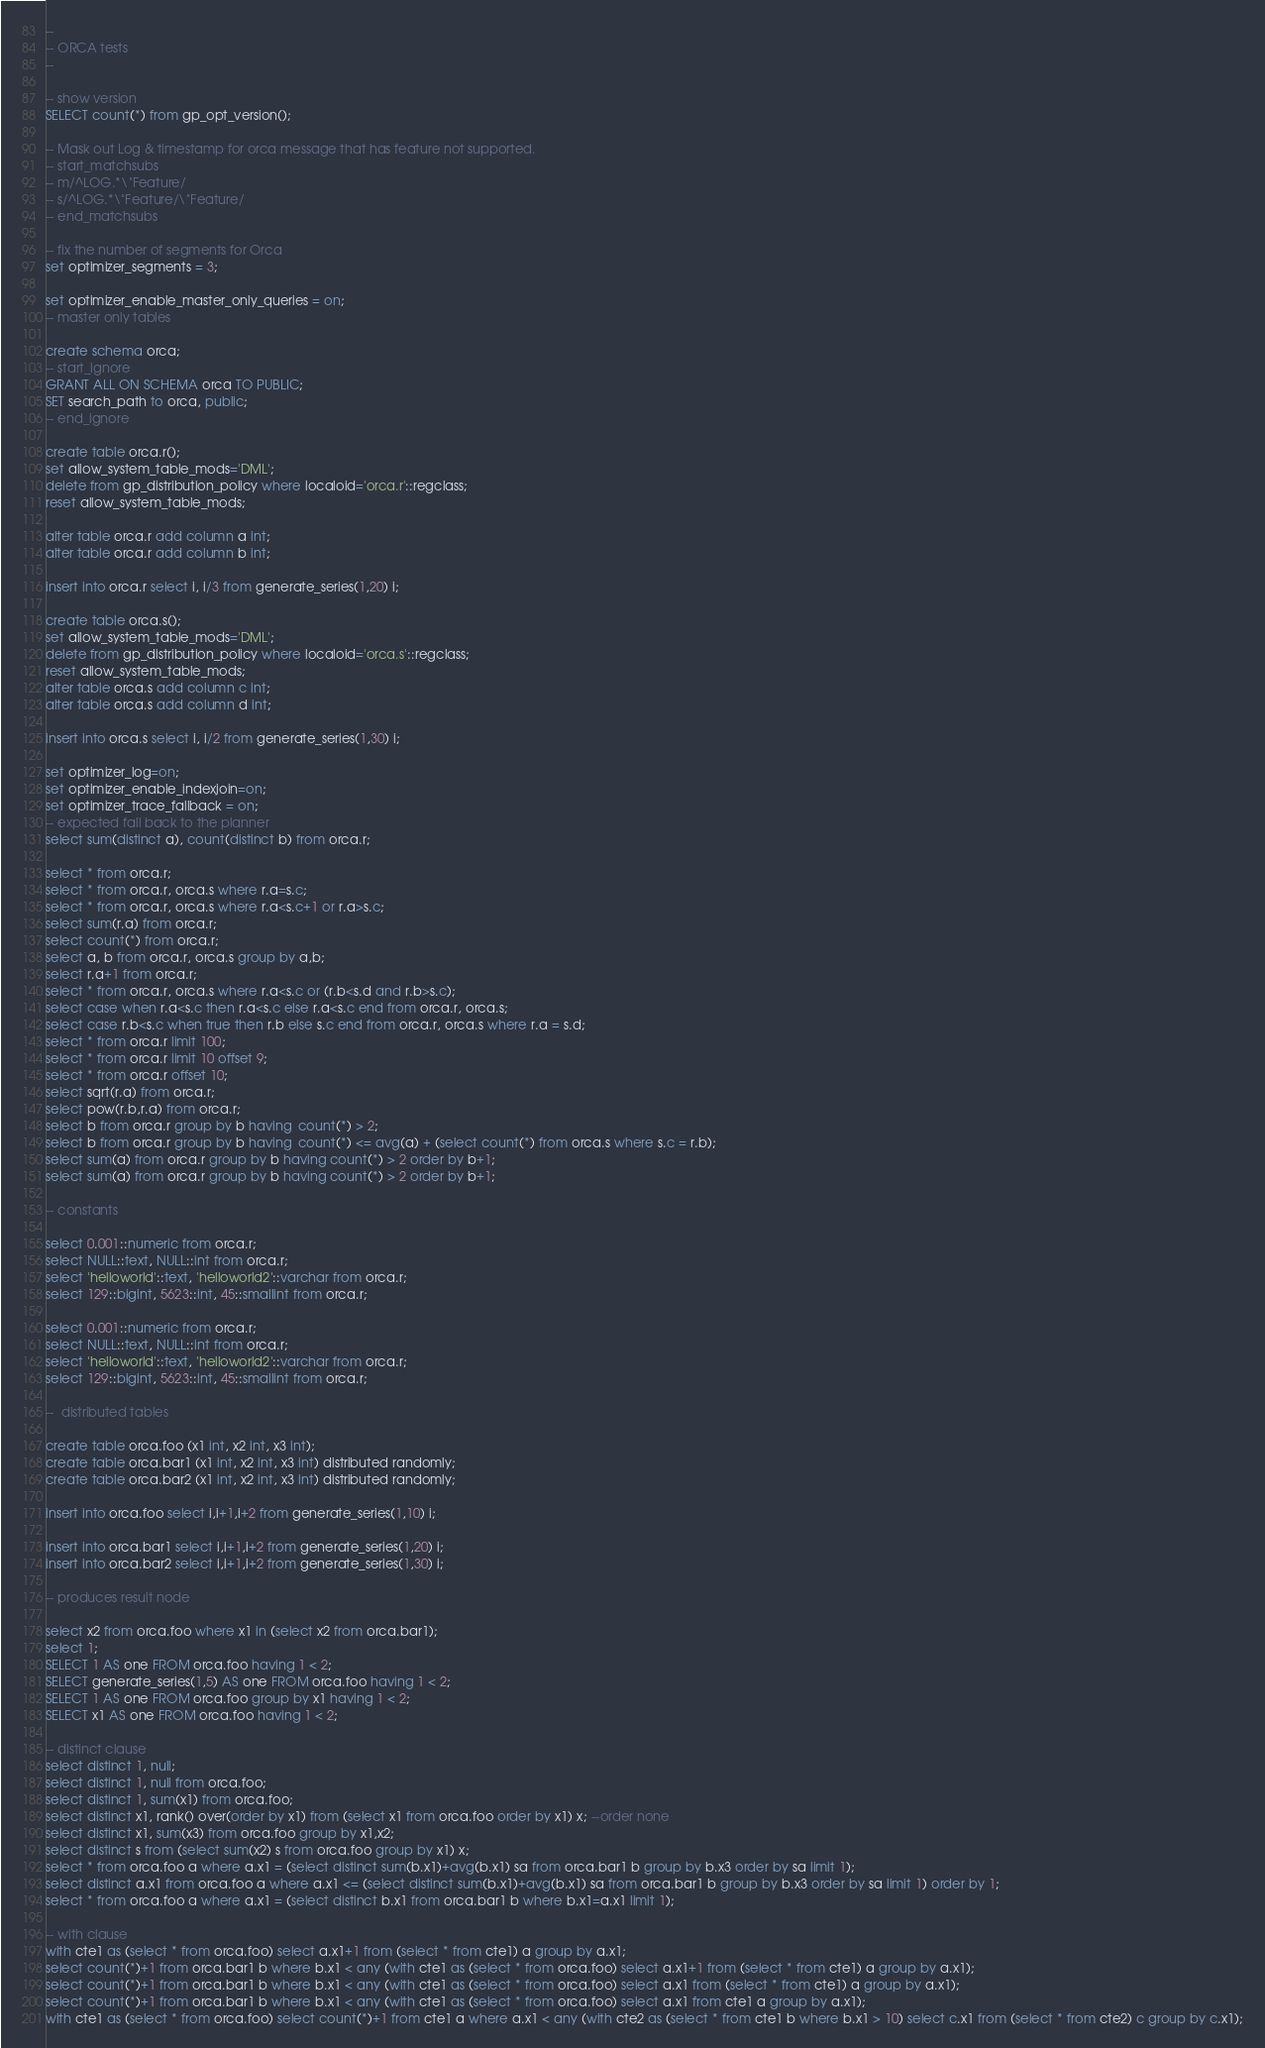<code> <loc_0><loc_0><loc_500><loc_500><_SQL_>--
-- ORCA tests
--

-- show version
SELECT count(*) from gp_opt_version();

-- Mask out Log & timestamp for orca message that has feature not supported.
-- start_matchsubs
-- m/^LOG.*\"Feature/
-- s/^LOG.*\"Feature/\"Feature/
-- end_matchsubs

-- fix the number of segments for Orca
set optimizer_segments = 3;

set optimizer_enable_master_only_queries = on;
-- master only tables

create schema orca;
-- start_ignore
GRANT ALL ON SCHEMA orca TO PUBLIC;
SET search_path to orca, public;
-- end_ignore

create table orca.r();
set allow_system_table_mods='DML';
delete from gp_distribution_policy where localoid='orca.r'::regclass;
reset allow_system_table_mods;

alter table orca.r add column a int;
alter table orca.r add column b int;

insert into orca.r select i, i/3 from generate_series(1,20) i;

create table orca.s();
set allow_system_table_mods='DML';
delete from gp_distribution_policy where localoid='orca.s'::regclass;
reset allow_system_table_mods;
alter table orca.s add column c int;
alter table orca.s add column d int;

insert into orca.s select i, i/2 from generate_series(1,30) i;

set optimizer_log=on;
set optimizer_enable_indexjoin=on;
set optimizer_trace_fallback = on;
-- expected fall back to the planner
select sum(distinct a), count(distinct b) from orca.r;

select * from orca.r;
select * from orca.r, orca.s where r.a=s.c;
select * from orca.r, orca.s where r.a<s.c+1 or r.a>s.c;
select sum(r.a) from orca.r;
select count(*) from orca.r;
select a, b from orca.r, orca.s group by a,b;
select r.a+1 from orca.r;
select * from orca.r, orca.s where r.a<s.c or (r.b<s.d and r.b>s.c);
select case when r.a<s.c then r.a<s.c else r.a<s.c end from orca.r, orca.s;
select case r.b<s.c when true then r.b else s.c end from orca.r, orca.s where r.a = s.d;
select * from orca.r limit 100;
select * from orca.r limit 10 offset 9;
select * from orca.r offset 10;
select sqrt(r.a) from orca.r;
select pow(r.b,r.a) from orca.r;
select b from orca.r group by b having  count(*) > 2;
select b from orca.r group by b having  count(*) <= avg(a) + (select count(*) from orca.s where s.c = r.b);
select sum(a) from orca.r group by b having count(*) > 2 order by b+1;
select sum(a) from orca.r group by b having count(*) > 2 order by b+1;

-- constants

select 0.001::numeric from orca.r;
select NULL::text, NULL::int from orca.r;
select 'helloworld'::text, 'helloworld2'::varchar from orca.r;
select 129::bigint, 5623::int, 45::smallint from orca.r;

select 0.001::numeric from orca.r;
select NULL::text, NULL::int from orca.r;
select 'helloworld'::text, 'helloworld2'::varchar from orca.r;
select 129::bigint, 5623::int, 45::smallint from orca.r;

--  distributed tables

create table orca.foo (x1 int, x2 int, x3 int);
create table orca.bar1 (x1 int, x2 int, x3 int) distributed randomly;
create table orca.bar2 (x1 int, x2 int, x3 int) distributed randomly;

insert into orca.foo select i,i+1,i+2 from generate_series(1,10) i;

insert into orca.bar1 select i,i+1,i+2 from generate_series(1,20) i;
insert into orca.bar2 select i,i+1,i+2 from generate_series(1,30) i;

-- produces result node

select x2 from orca.foo where x1 in (select x2 from orca.bar1);
select 1;
SELECT 1 AS one FROM orca.foo having 1 < 2;
SELECT generate_series(1,5) AS one FROM orca.foo having 1 < 2;
SELECT 1 AS one FROM orca.foo group by x1 having 1 < 2;
SELECT x1 AS one FROM orca.foo having 1 < 2;

-- distinct clause
select distinct 1, null;
select distinct 1, null from orca.foo;
select distinct 1, sum(x1) from orca.foo;
select distinct x1, rank() over(order by x1) from (select x1 from orca.foo order by x1) x; --order none
select distinct x1, sum(x3) from orca.foo group by x1,x2;
select distinct s from (select sum(x2) s from orca.foo group by x1) x;
select * from orca.foo a where a.x1 = (select distinct sum(b.x1)+avg(b.x1) sa from orca.bar1 b group by b.x3 order by sa limit 1);
select distinct a.x1 from orca.foo a where a.x1 <= (select distinct sum(b.x1)+avg(b.x1) sa from orca.bar1 b group by b.x3 order by sa limit 1) order by 1;
select * from orca.foo a where a.x1 = (select distinct b.x1 from orca.bar1 b where b.x1=a.x1 limit 1);

-- with clause
with cte1 as (select * from orca.foo) select a.x1+1 from (select * from cte1) a group by a.x1;
select count(*)+1 from orca.bar1 b where b.x1 < any (with cte1 as (select * from orca.foo) select a.x1+1 from (select * from cte1) a group by a.x1);
select count(*)+1 from orca.bar1 b where b.x1 < any (with cte1 as (select * from orca.foo) select a.x1 from (select * from cte1) a group by a.x1);
select count(*)+1 from orca.bar1 b where b.x1 < any (with cte1 as (select * from orca.foo) select a.x1 from cte1 a group by a.x1);
with cte1 as (select * from orca.foo) select count(*)+1 from cte1 a where a.x1 < any (with cte2 as (select * from cte1 b where b.x1 > 10) select c.x1 from (select * from cte2) c group by c.x1);</code> 